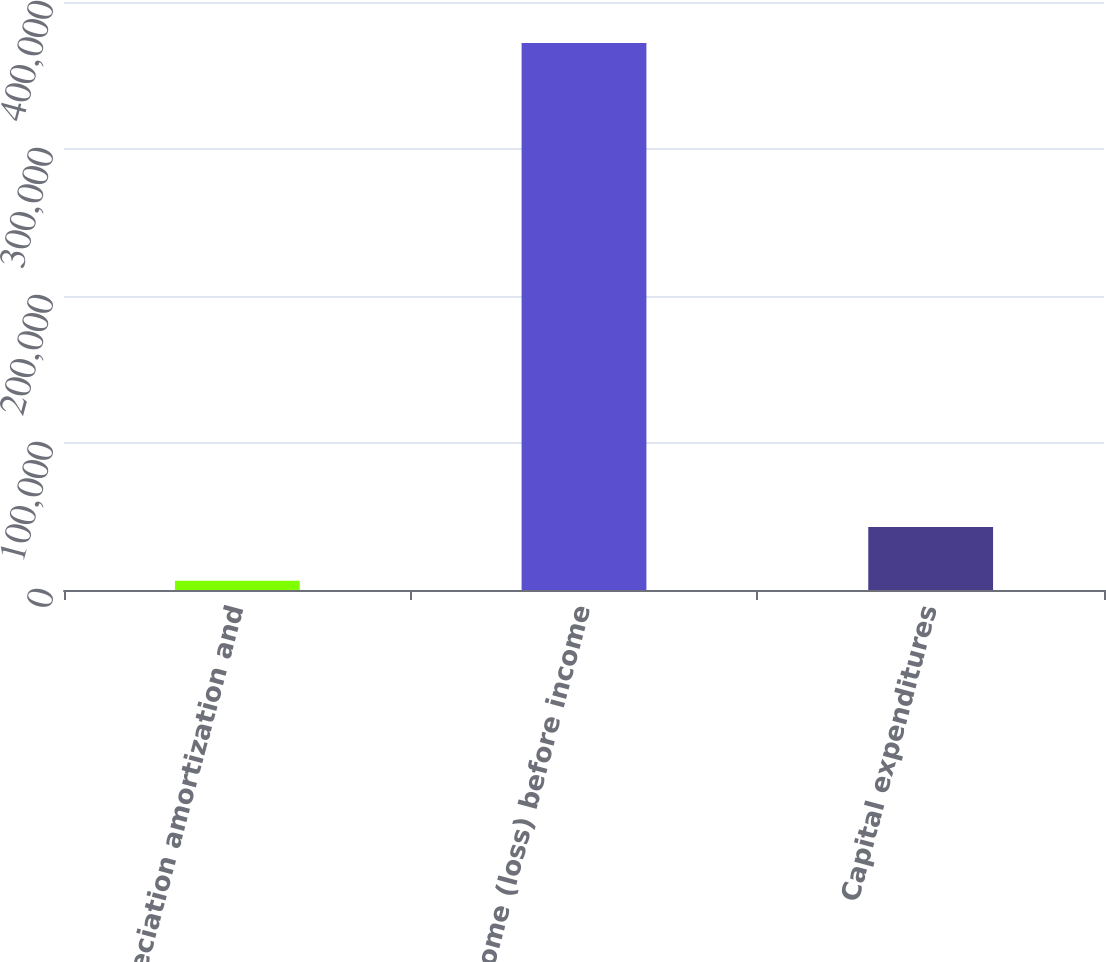Convert chart. <chart><loc_0><loc_0><loc_500><loc_500><bar_chart><fcel>Depreciation amortization and<fcel>Income (loss) before income<fcel>Capital expenditures<nl><fcel>6274<fcel>372039<fcel>42850.5<nl></chart> 